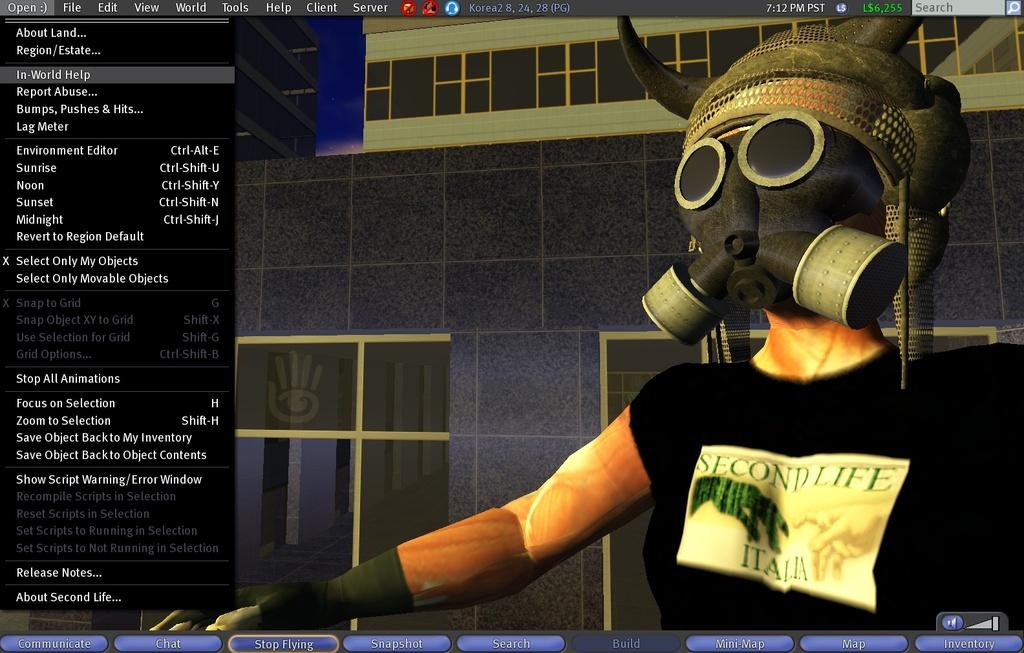What type of image is shown in the screenshot? The image is a screenshot of a desktop screen. What is the context of the screenshot? The screenshot appears to be from a game. Can you describe the animated image in the screenshot? There is an animated image in the screenshot. What can be found on the left side of the screenshot? There are different options on the left side of the screenshot. How does the boy contribute to the teaching aspect of the game in the screenshot? There is no boy present in the screenshot, and the screenshot does not depict any teaching aspect. 